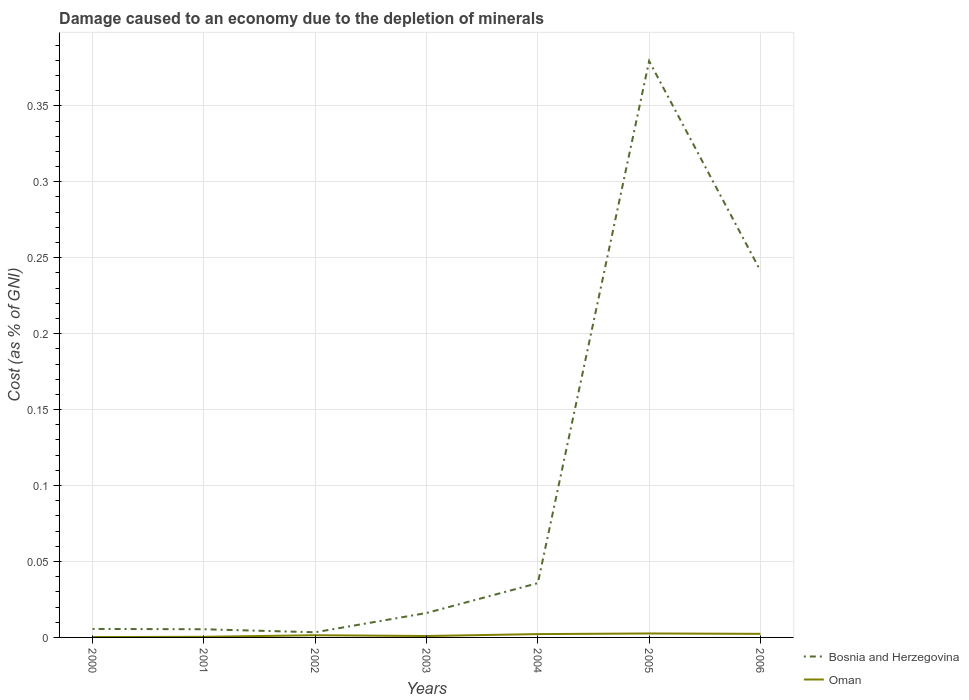Is the number of lines equal to the number of legend labels?
Your answer should be very brief. Yes. Across all years, what is the maximum cost of damage caused due to the depletion of minerals in Bosnia and Herzegovina?
Keep it short and to the point. 0. In which year was the cost of damage caused due to the depletion of minerals in Bosnia and Herzegovina maximum?
Offer a terse response. 2002. What is the total cost of damage caused due to the depletion of minerals in Bosnia and Herzegovina in the graph?
Make the answer very short. -0.24. What is the difference between the highest and the second highest cost of damage caused due to the depletion of minerals in Oman?
Your response must be concise. 0. What is the difference between the highest and the lowest cost of damage caused due to the depletion of minerals in Bosnia and Herzegovina?
Provide a short and direct response. 2. Is the cost of damage caused due to the depletion of minerals in Oman strictly greater than the cost of damage caused due to the depletion of minerals in Bosnia and Herzegovina over the years?
Provide a short and direct response. Yes. What is the difference between two consecutive major ticks on the Y-axis?
Make the answer very short. 0.05. Are the values on the major ticks of Y-axis written in scientific E-notation?
Make the answer very short. No. How many legend labels are there?
Give a very brief answer. 2. What is the title of the graph?
Offer a terse response. Damage caused to an economy due to the depletion of minerals. What is the label or title of the Y-axis?
Provide a short and direct response. Cost (as % of GNI). What is the Cost (as % of GNI) of Bosnia and Herzegovina in 2000?
Your response must be concise. 0.01. What is the Cost (as % of GNI) of Oman in 2000?
Make the answer very short. 0. What is the Cost (as % of GNI) of Bosnia and Herzegovina in 2001?
Provide a succinct answer. 0.01. What is the Cost (as % of GNI) of Oman in 2001?
Your answer should be very brief. 0. What is the Cost (as % of GNI) of Bosnia and Herzegovina in 2002?
Your answer should be compact. 0. What is the Cost (as % of GNI) of Oman in 2002?
Make the answer very short. 0. What is the Cost (as % of GNI) of Bosnia and Herzegovina in 2003?
Offer a terse response. 0.02. What is the Cost (as % of GNI) in Oman in 2003?
Offer a terse response. 0. What is the Cost (as % of GNI) of Bosnia and Herzegovina in 2004?
Offer a terse response. 0.04. What is the Cost (as % of GNI) of Oman in 2004?
Make the answer very short. 0. What is the Cost (as % of GNI) of Bosnia and Herzegovina in 2005?
Your answer should be very brief. 0.38. What is the Cost (as % of GNI) of Oman in 2005?
Make the answer very short. 0. What is the Cost (as % of GNI) in Bosnia and Herzegovina in 2006?
Make the answer very short. 0.24. What is the Cost (as % of GNI) in Oman in 2006?
Keep it short and to the point. 0. Across all years, what is the maximum Cost (as % of GNI) in Bosnia and Herzegovina?
Your answer should be very brief. 0.38. Across all years, what is the maximum Cost (as % of GNI) of Oman?
Ensure brevity in your answer.  0. Across all years, what is the minimum Cost (as % of GNI) of Bosnia and Herzegovina?
Your answer should be compact. 0. Across all years, what is the minimum Cost (as % of GNI) of Oman?
Your answer should be very brief. 0. What is the total Cost (as % of GNI) of Bosnia and Herzegovina in the graph?
Ensure brevity in your answer.  0.69. What is the total Cost (as % of GNI) of Oman in the graph?
Your answer should be very brief. 0.01. What is the difference between the Cost (as % of GNI) in Bosnia and Herzegovina in 2000 and that in 2001?
Provide a succinct answer. 0. What is the difference between the Cost (as % of GNI) of Oman in 2000 and that in 2001?
Ensure brevity in your answer.  -0. What is the difference between the Cost (as % of GNI) of Bosnia and Herzegovina in 2000 and that in 2002?
Your answer should be very brief. 0. What is the difference between the Cost (as % of GNI) in Oman in 2000 and that in 2002?
Offer a terse response. -0. What is the difference between the Cost (as % of GNI) of Bosnia and Herzegovina in 2000 and that in 2003?
Provide a succinct answer. -0.01. What is the difference between the Cost (as % of GNI) of Oman in 2000 and that in 2003?
Provide a succinct answer. -0. What is the difference between the Cost (as % of GNI) of Bosnia and Herzegovina in 2000 and that in 2004?
Provide a short and direct response. -0.03. What is the difference between the Cost (as % of GNI) of Oman in 2000 and that in 2004?
Offer a terse response. -0. What is the difference between the Cost (as % of GNI) of Bosnia and Herzegovina in 2000 and that in 2005?
Provide a succinct answer. -0.37. What is the difference between the Cost (as % of GNI) of Oman in 2000 and that in 2005?
Your answer should be compact. -0. What is the difference between the Cost (as % of GNI) in Bosnia and Herzegovina in 2000 and that in 2006?
Make the answer very short. -0.24. What is the difference between the Cost (as % of GNI) in Oman in 2000 and that in 2006?
Offer a very short reply. -0. What is the difference between the Cost (as % of GNI) of Bosnia and Herzegovina in 2001 and that in 2002?
Keep it short and to the point. 0. What is the difference between the Cost (as % of GNI) in Oman in 2001 and that in 2002?
Offer a very short reply. -0. What is the difference between the Cost (as % of GNI) in Bosnia and Herzegovina in 2001 and that in 2003?
Ensure brevity in your answer.  -0.01. What is the difference between the Cost (as % of GNI) of Oman in 2001 and that in 2003?
Offer a very short reply. -0. What is the difference between the Cost (as % of GNI) of Bosnia and Herzegovina in 2001 and that in 2004?
Offer a very short reply. -0.03. What is the difference between the Cost (as % of GNI) of Oman in 2001 and that in 2004?
Offer a terse response. -0. What is the difference between the Cost (as % of GNI) in Bosnia and Herzegovina in 2001 and that in 2005?
Provide a short and direct response. -0.37. What is the difference between the Cost (as % of GNI) in Oman in 2001 and that in 2005?
Provide a short and direct response. -0. What is the difference between the Cost (as % of GNI) in Bosnia and Herzegovina in 2001 and that in 2006?
Make the answer very short. -0.24. What is the difference between the Cost (as % of GNI) in Oman in 2001 and that in 2006?
Offer a very short reply. -0. What is the difference between the Cost (as % of GNI) of Bosnia and Herzegovina in 2002 and that in 2003?
Ensure brevity in your answer.  -0.01. What is the difference between the Cost (as % of GNI) in Bosnia and Herzegovina in 2002 and that in 2004?
Give a very brief answer. -0.03. What is the difference between the Cost (as % of GNI) of Oman in 2002 and that in 2004?
Give a very brief answer. -0. What is the difference between the Cost (as % of GNI) of Bosnia and Herzegovina in 2002 and that in 2005?
Make the answer very short. -0.38. What is the difference between the Cost (as % of GNI) in Oman in 2002 and that in 2005?
Make the answer very short. -0. What is the difference between the Cost (as % of GNI) of Bosnia and Herzegovina in 2002 and that in 2006?
Offer a very short reply. -0.24. What is the difference between the Cost (as % of GNI) in Oman in 2002 and that in 2006?
Give a very brief answer. -0. What is the difference between the Cost (as % of GNI) in Bosnia and Herzegovina in 2003 and that in 2004?
Your answer should be compact. -0.02. What is the difference between the Cost (as % of GNI) in Oman in 2003 and that in 2004?
Make the answer very short. -0. What is the difference between the Cost (as % of GNI) in Bosnia and Herzegovina in 2003 and that in 2005?
Make the answer very short. -0.36. What is the difference between the Cost (as % of GNI) in Oman in 2003 and that in 2005?
Give a very brief answer. -0. What is the difference between the Cost (as % of GNI) in Bosnia and Herzegovina in 2003 and that in 2006?
Your response must be concise. -0.23. What is the difference between the Cost (as % of GNI) in Oman in 2003 and that in 2006?
Offer a terse response. -0. What is the difference between the Cost (as % of GNI) of Bosnia and Herzegovina in 2004 and that in 2005?
Make the answer very short. -0.34. What is the difference between the Cost (as % of GNI) in Oman in 2004 and that in 2005?
Your answer should be very brief. -0. What is the difference between the Cost (as % of GNI) in Bosnia and Herzegovina in 2004 and that in 2006?
Offer a terse response. -0.21. What is the difference between the Cost (as % of GNI) in Oman in 2004 and that in 2006?
Your answer should be very brief. -0. What is the difference between the Cost (as % of GNI) in Bosnia and Herzegovina in 2005 and that in 2006?
Offer a terse response. 0.14. What is the difference between the Cost (as % of GNI) in Bosnia and Herzegovina in 2000 and the Cost (as % of GNI) in Oman in 2001?
Offer a terse response. 0.01. What is the difference between the Cost (as % of GNI) of Bosnia and Herzegovina in 2000 and the Cost (as % of GNI) of Oman in 2002?
Your answer should be very brief. 0. What is the difference between the Cost (as % of GNI) in Bosnia and Herzegovina in 2000 and the Cost (as % of GNI) in Oman in 2003?
Offer a very short reply. 0. What is the difference between the Cost (as % of GNI) in Bosnia and Herzegovina in 2000 and the Cost (as % of GNI) in Oman in 2004?
Offer a terse response. 0. What is the difference between the Cost (as % of GNI) in Bosnia and Herzegovina in 2000 and the Cost (as % of GNI) in Oman in 2005?
Offer a very short reply. 0. What is the difference between the Cost (as % of GNI) in Bosnia and Herzegovina in 2000 and the Cost (as % of GNI) in Oman in 2006?
Your answer should be very brief. 0. What is the difference between the Cost (as % of GNI) in Bosnia and Herzegovina in 2001 and the Cost (as % of GNI) in Oman in 2002?
Give a very brief answer. 0. What is the difference between the Cost (as % of GNI) in Bosnia and Herzegovina in 2001 and the Cost (as % of GNI) in Oman in 2003?
Provide a short and direct response. 0. What is the difference between the Cost (as % of GNI) in Bosnia and Herzegovina in 2001 and the Cost (as % of GNI) in Oman in 2004?
Keep it short and to the point. 0. What is the difference between the Cost (as % of GNI) in Bosnia and Herzegovina in 2001 and the Cost (as % of GNI) in Oman in 2005?
Ensure brevity in your answer.  0. What is the difference between the Cost (as % of GNI) in Bosnia and Herzegovina in 2001 and the Cost (as % of GNI) in Oman in 2006?
Your answer should be very brief. 0. What is the difference between the Cost (as % of GNI) in Bosnia and Herzegovina in 2002 and the Cost (as % of GNI) in Oman in 2003?
Offer a terse response. 0. What is the difference between the Cost (as % of GNI) in Bosnia and Herzegovina in 2002 and the Cost (as % of GNI) in Oman in 2004?
Provide a short and direct response. 0. What is the difference between the Cost (as % of GNI) in Bosnia and Herzegovina in 2002 and the Cost (as % of GNI) in Oman in 2005?
Ensure brevity in your answer.  0. What is the difference between the Cost (as % of GNI) of Bosnia and Herzegovina in 2002 and the Cost (as % of GNI) of Oman in 2006?
Provide a succinct answer. 0. What is the difference between the Cost (as % of GNI) in Bosnia and Herzegovina in 2003 and the Cost (as % of GNI) in Oman in 2004?
Your answer should be very brief. 0.01. What is the difference between the Cost (as % of GNI) in Bosnia and Herzegovina in 2003 and the Cost (as % of GNI) in Oman in 2005?
Provide a succinct answer. 0.01. What is the difference between the Cost (as % of GNI) in Bosnia and Herzegovina in 2003 and the Cost (as % of GNI) in Oman in 2006?
Provide a short and direct response. 0.01. What is the difference between the Cost (as % of GNI) in Bosnia and Herzegovina in 2004 and the Cost (as % of GNI) in Oman in 2005?
Give a very brief answer. 0.03. What is the difference between the Cost (as % of GNI) of Bosnia and Herzegovina in 2004 and the Cost (as % of GNI) of Oman in 2006?
Offer a very short reply. 0.03. What is the difference between the Cost (as % of GNI) of Bosnia and Herzegovina in 2005 and the Cost (as % of GNI) of Oman in 2006?
Your answer should be compact. 0.38. What is the average Cost (as % of GNI) in Bosnia and Herzegovina per year?
Provide a short and direct response. 0.1. What is the average Cost (as % of GNI) in Oman per year?
Your response must be concise. 0. In the year 2000, what is the difference between the Cost (as % of GNI) in Bosnia and Herzegovina and Cost (as % of GNI) in Oman?
Your answer should be very brief. 0.01. In the year 2001, what is the difference between the Cost (as % of GNI) of Bosnia and Herzegovina and Cost (as % of GNI) of Oman?
Ensure brevity in your answer.  0.01. In the year 2002, what is the difference between the Cost (as % of GNI) in Bosnia and Herzegovina and Cost (as % of GNI) in Oman?
Give a very brief answer. 0. In the year 2003, what is the difference between the Cost (as % of GNI) of Bosnia and Herzegovina and Cost (as % of GNI) of Oman?
Provide a succinct answer. 0.02. In the year 2004, what is the difference between the Cost (as % of GNI) in Bosnia and Herzegovina and Cost (as % of GNI) in Oman?
Your answer should be very brief. 0.03. In the year 2005, what is the difference between the Cost (as % of GNI) in Bosnia and Herzegovina and Cost (as % of GNI) in Oman?
Provide a succinct answer. 0.38. In the year 2006, what is the difference between the Cost (as % of GNI) of Bosnia and Herzegovina and Cost (as % of GNI) of Oman?
Offer a very short reply. 0.24. What is the ratio of the Cost (as % of GNI) in Bosnia and Herzegovina in 2000 to that in 2001?
Your response must be concise. 1.04. What is the ratio of the Cost (as % of GNI) of Oman in 2000 to that in 2001?
Make the answer very short. 0.59. What is the ratio of the Cost (as % of GNI) of Bosnia and Herzegovina in 2000 to that in 2002?
Your answer should be very brief. 1.65. What is the ratio of the Cost (as % of GNI) in Oman in 2000 to that in 2002?
Offer a terse response. 0.17. What is the ratio of the Cost (as % of GNI) in Bosnia and Herzegovina in 2000 to that in 2003?
Keep it short and to the point. 0.35. What is the ratio of the Cost (as % of GNI) in Oman in 2000 to that in 2003?
Your response must be concise. 0.26. What is the ratio of the Cost (as % of GNI) in Bosnia and Herzegovina in 2000 to that in 2004?
Keep it short and to the point. 0.16. What is the ratio of the Cost (as % of GNI) in Oman in 2000 to that in 2004?
Keep it short and to the point. 0.11. What is the ratio of the Cost (as % of GNI) of Bosnia and Herzegovina in 2000 to that in 2005?
Provide a short and direct response. 0.01. What is the ratio of the Cost (as % of GNI) of Oman in 2000 to that in 2005?
Provide a short and direct response. 0.09. What is the ratio of the Cost (as % of GNI) of Bosnia and Herzegovina in 2000 to that in 2006?
Ensure brevity in your answer.  0.02. What is the ratio of the Cost (as % of GNI) of Oman in 2000 to that in 2006?
Provide a short and direct response. 0.1. What is the ratio of the Cost (as % of GNI) of Bosnia and Herzegovina in 2001 to that in 2002?
Provide a short and direct response. 1.59. What is the ratio of the Cost (as % of GNI) of Oman in 2001 to that in 2002?
Keep it short and to the point. 0.28. What is the ratio of the Cost (as % of GNI) in Bosnia and Herzegovina in 2001 to that in 2003?
Offer a very short reply. 0.33. What is the ratio of the Cost (as % of GNI) in Oman in 2001 to that in 2003?
Your answer should be very brief. 0.44. What is the ratio of the Cost (as % of GNI) in Bosnia and Herzegovina in 2001 to that in 2004?
Make the answer very short. 0.15. What is the ratio of the Cost (as % of GNI) in Oman in 2001 to that in 2004?
Provide a succinct answer. 0.19. What is the ratio of the Cost (as % of GNI) of Bosnia and Herzegovina in 2001 to that in 2005?
Ensure brevity in your answer.  0.01. What is the ratio of the Cost (as % of GNI) of Oman in 2001 to that in 2005?
Keep it short and to the point. 0.16. What is the ratio of the Cost (as % of GNI) in Bosnia and Herzegovina in 2001 to that in 2006?
Your response must be concise. 0.02. What is the ratio of the Cost (as % of GNI) in Oman in 2001 to that in 2006?
Provide a succinct answer. 0.17. What is the ratio of the Cost (as % of GNI) in Bosnia and Herzegovina in 2002 to that in 2003?
Your response must be concise. 0.21. What is the ratio of the Cost (as % of GNI) in Oman in 2002 to that in 2003?
Offer a terse response. 1.56. What is the ratio of the Cost (as % of GNI) of Bosnia and Herzegovina in 2002 to that in 2004?
Keep it short and to the point. 0.1. What is the ratio of the Cost (as % of GNI) of Oman in 2002 to that in 2004?
Give a very brief answer. 0.67. What is the ratio of the Cost (as % of GNI) in Bosnia and Herzegovina in 2002 to that in 2005?
Provide a succinct answer. 0.01. What is the ratio of the Cost (as % of GNI) of Oman in 2002 to that in 2005?
Provide a succinct answer. 0.56. What is the ratio of the Cost (as % of GNI) in Bosnia and Herzegovina in 2002 to that in 2006?
Make the answer very short. 0.01. What is the ratio of the Cost (as % of GNI) of Oman in 2002 to that in 2006?
Your response must be concise. 0.62. What is the ratio of the Cost (as % of GNI) of Bosnia and Herzegovina in 2003 to that in 2004?
Provide a succinct answer. 0.45. What is the ratio of the Cost (as % of GNI) of Oman in 2003 to that in 2004?
Provide a succinct answer. 0.43. What is the ratio of the Cost (as % of GNI) of Bosnia and Herzegovina in 2003 to that in 2005?
Make the answer very short. 0.04. What is the ratio of the Cost (as % of GNI) in Oman in 2003 to that in 2005?
Your response must be concise. 0.36. What is the ratio of the Cost (as % of GNI) in Bosnia and Herzegovina in 2003 to that in 2006?
Make the answer very short. 0.07. What is the ratio of the Cost (as % of GNI) of Oman in 2003 to that in 2006?
Provide a short and direct response. 0.4. What is the ratio of the Cost (as % of GNI) in Bosnia and Herzegovina in 2004 to that in 2005?
Offer a terse response. 0.09. What is the ratio of the Cost (as % of GNI) in Oman in 2004 to that in 2005?
Your answer should be compact. 0.84. What is the ratio of the Cost (as % of GNI) in Bosnia and Herzegovina in 2004 to that in 2006?
Keep it short and to the point. 0.15. What is the ratio of the Cost (as % of GNI) of Oman in 2004 to that in 2006?
Offer a very short reply. 0.93. What is the ratio of the Cost (as % of GNI) of Bosnia and Herzegovina in 2005 to that in 2006?
Offer a terse response. 1.57. What is the ratio of the Cost (as % of GNI) of Oman in 2005 to that in 2006?
Provide a short and direct response. 1.11. What is the difference between the highest and the second highest Cost (as % of GNI) of Bosnia and Herzegovina?
Ensure brevity in your answer.  0.14. What is the difference between the highest and the second highest Cost (as % of GNI) of Oman?
Ensure brevity in your answer.  0. What is the difference between the highest and the lowest Cost (as % of GNI) of Bosnia and Herzegovina?
Give a very brief answer. 0.38. What is the difference between the highest and the lowest Cost (as % of GNI) of Oman?
Offer a terse response. 0. 